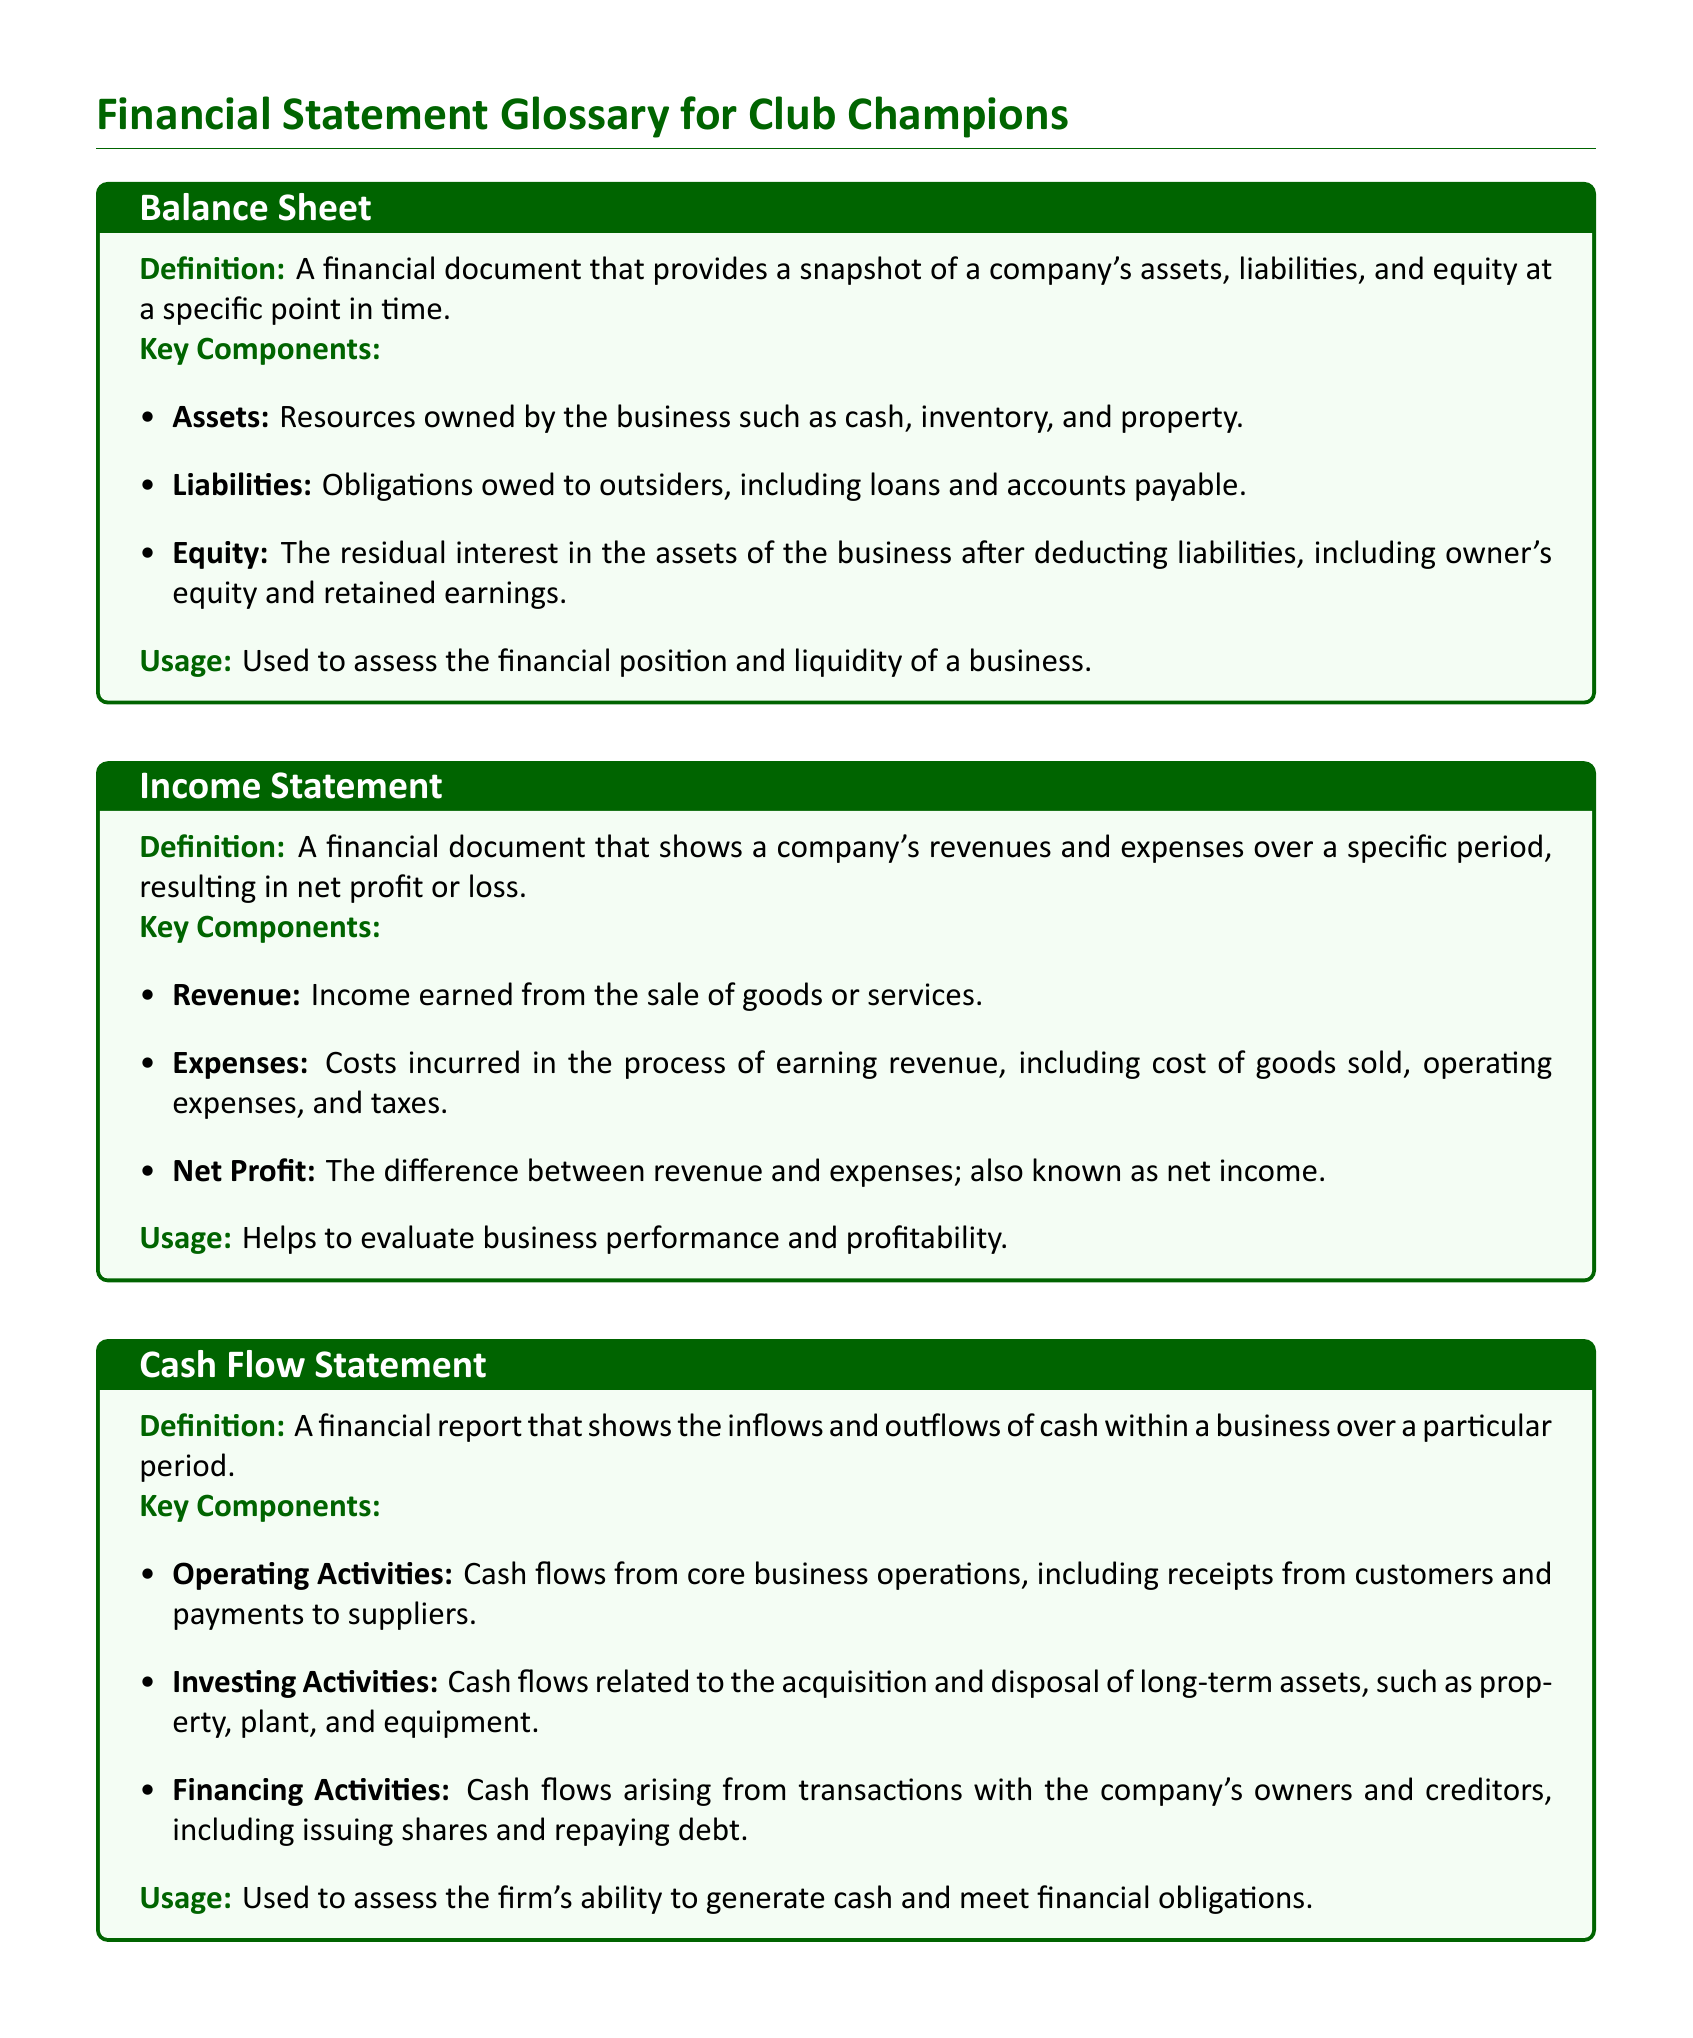what is a balance sheet? A balance sheet is defined as a financial document that provides a snapshot of a company's assets, liabilities, and equity at a specific point in time.
Answer: financial document what are the key components of an income statement? The key components of an income statement include revenue, expenses, and net profit.
Answer: revenue, expenses, net profit what does equity represent? Equity represents the value of the owner's interest in the business, after all liabilities have been subtracted from assets.
Answer: owner's interest what is the focus of the cash flow statement? The focus of the cash flow statement is to show the inflows and outflows of cash within a business over a particular period.
Answer: cash inflows and outflows how does retained earnings affect equity? Retained earnings contribute to equity as they are profits reinvested in the business rather than distributed as dividends.
Answer: contribute to equity what are operating activities in the cash flow statement? Operating activities in the cash flow statement refer to cash flows from core business operations, including receipts from customers and payments to suppliers.
Answer: core business operations what is used to assess financial position? A balance sheet is used to assess the financial position and liquidity of a business.
Answer: balance sheet which financial statement helps evaluate profitability? The income statement helps evaluate business performance and profitability.
Answer: income statement what do liabilities represent? Liabilities represent obligations owed to outsiders, including loans and accounts payable.
Answer: obligations owed to outsiders 